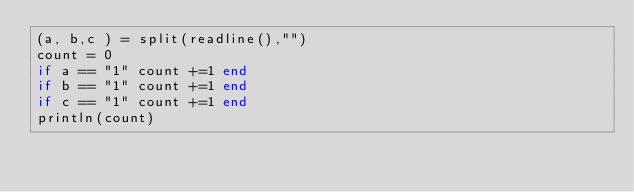<code> <loc_0><loc_0><loc_500><loc_500><_Julia_>(a, b,c ) = split(readline(),"")
count = 0
if a == "1" count +=1 end
if b == "1" count +=1 end
if c == "1" count +=1 end
println(count)</code> 